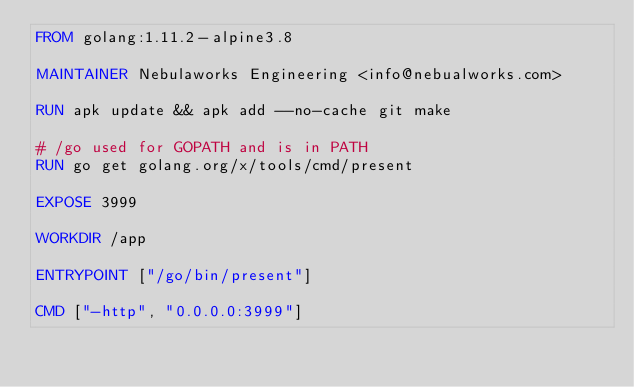<code> <loc_0><loc_0><loc_500><loc_500><_Dockerfile_>FROM golang:1.11.2-alpine3.8

MAINTAINER Nebulaworks Engineering <info@nebualworks.com>

RUN apk update && apk add --no-cache git make

# /go used for GOPATH and is in PATH
RUN go get golang.org/x/tools/cmd/present

EXPOSE 3999

WORKDIR /app

ENTRYPOINT ["/go/bin/present"]

CMD ["-http", "0.0.0.0:3999"]
</code> 